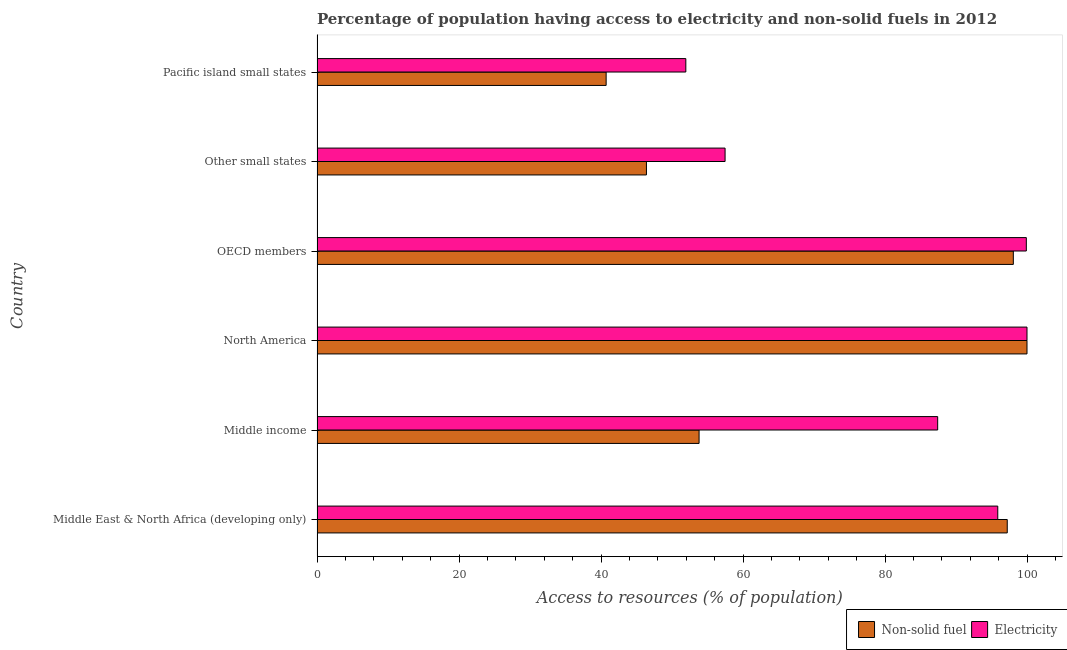How many different coloured bars are there?
Provide a succinct answer. 2. How many groups of bars are there?
Your answer should be very brief. 6. Are the number of bars on each tick of the Y-axis equal?
Offer a terse response. Yes. How many bars are there on the 6th tick from the top?
Provide a short and direct response. 2. How many bars are there on the 5th tick from the bottom?
Your answer should be very brief. 2. What is the label of the 1st group of bars from the top?
Provide a short and direct response. Pacific island small states. What is the percentage of population having access to non-solid fuel in Middle East & North Africa (developing only)?
Your answer should be compact. 97.22. Across all countries, what is the minimum percentage of population having access to non-solid fuel?
Keep it short and to the point. 40.72. In which country was the percentage of population having access to non-solid fuel minimum?
Make the answer very short. Pacific island small states. What is the total percentage of population having access to non-solid fuel in the graph?
Keep it short and to the point. 436.22. What is the difference between the percentage of population having access to non-solid fuel in Middle income and that in North America?
Your answer should be very brief. -46.19. What is the difference between the percentage of population having access to non-solid fuel in Pacific island small states and the percentage of population having access to electricity in OECD members?
Your answer should be compact. -59.19. What is the average percentage of population having access to non-solid fuel per country?
Keep it short and to the point. 72.7. What is the difference between the percentage of population having access to non-solid fuel and percentage of population having access to electricity in Middle East & North Africa (developing only)?
Make the answer very short. 1.34. What is the ratio of the percentage of population having access to electricity in Middle East & North Africa (developing only) to that in Middle income?
Keep it short and to the point. 1.1. Is the percentage of population having access to non-solid fuel in North America less than that in Pacific island small states?
Ensure brevity in your answer.  No. Is the difference between the percentage of population having access to non-solid fuel in Middle income and Pacific island small states greater than the difference between the percentage of population having access to electricity in Middle income and Pacific island small states?
Provide a succinct answer. No. What is the difference between the highest and the second highest percentage of population having access to electricity?
Offer a terse response. 0.09. What is the difference between the highest and the lowest percentage of population having access to electricity?
Your answer should be compact. 48.06. Is the sum of the percentage of population having access to electricity in Middle East & North Africa (developing only) and North America greater than the maximum percentage of population having access to non-solid fuel across all countries?
Give a very brief answer. Yes. What does the 2nd bar from the top in OECD members represents?
Offer a terse response. Non-solid fuel. What does the 1st bar from the bottom in North America represents?
Your answer should be compact. Non-solid fuel. What is the difference between two consecutive major ticks on the X-axis?
Give a very brief answer. 20. Does the graph contain any zero values?
Offer a very short reply. No. Does the graph contain grids?
Give a very brief answer. No. Where does the legend appear in the graph?
Ensure brevity in your answer.  Bottom right. What is the title of the graph?
Provide a succinct answer. Percentage of population having access to electricity and non-solid fuels in 2012. What is the label or title of the X-axis?
Provide a short and direct response. Access to resources (% of population). What is the Access to resources (% of population) in Non-solid fuel in Middle East & North Africa (developing only)?
Your response must be concise. 97.22. What is the Access to resources (% of population) of Electricity in Middle East & North Africa (developing only)?
Give a very brief answer. 95.88. What is the Access to resources (% of population) of Non-solid fuel in Middle income?
Your response must be concise. 53.81. What is the Access to resources (% of population) in Electricity in Middle income?
Your answer should be compact. 87.42. What is the Access to resources (% of population) of Non-solid fuel in North America?
Offer a terse response. 100. What is the Access to resources (% of population) of Electricity in North America?
Keep it short and to the point. 100. What is the Access to resources (% of population) in Non-solid fuel in OECD members?
Your response must be concise. 98.07. What is the Access to resources (% of population) of Electricity in OECD members?
Ensure brevity in your answer.  99.91. What is the Access to resources (% of population) of Non-solid fuel in Other small states?
Give a very brief answer. 46.4. What is the Access to resources (% of population) of Electricity in Other small states?
Your answer should be very brief. 57.47. What is the Access to resources (% of population) of Non-solid fuel in Pacific island small states?
Offer a terse response. 40.72. What is the Access to resources (% of population) in Electricity in Pacific island small states?
Keep it short and to the point. 51.94. Across all countries, what is the maximum Access to resources (% of population) of Non-solid fuel?
Offer a terse response. 100. Across all countries, what is the maximum Access to resources (% of population) of Electricity?
Offer a terse response. 100. Across all countries, what is the minimum Access to resources (% of population) of Non-solid fuel?
Make the answer very short. 40.72. Across all countries, what is the minimum Access to resources (% of population) in Electricity?
Provide a succinct answer. 51.94. What is the total Access to resources (% of population) of Non-solid fuel in the graph?
Provide a succinct answer. 436.22. What is the total Access to resources (% of population) of Electricity in the graph?
Your answer should be compact. 492.63. What is the difference between the Access to resources (% of population) in Non-solid fuel in Middle East & North Africa (developing only) and that in Middle income?
Ensure brevity in your answer.  43.41. What is the difference between the Access to resources (% of population) of Electricity in Middle East & North Africa (developing only) and that in Middle income?
Your response must be concise. 8.47. What is the difference between the Access to resources (% of population) of Non-solid fuel in Middle East & North Africa (developing only) and that in North America?
Your answer should be compact. -2.78. What is the difference between the Access to resources (% of population) in Electricity in Middle East & North Africa (developing only) and that in North America?
Provide a succinct answer. -4.12. What is the difference between the Access to resources (% of population) in Non-solid fuel in Middle East & North Africa (developing only) and that in OECD members?
Ensure brevity in your answer.  -0.85. What is the difference between the Access to resources (% of population) in Electricity in Middle East & North Africa (developing only) and that in OECD members?
Offer a terse response. -4.02. What is the difference between the Access to resources (% of population) of Non-solid fuel in Middle East & North Africa (developing only) and that in Other small states?
Your answer should be compact. 50.82. What is the difference between the Access to resources (% of population) of Electricity in Middle East & North Africa (developing only) and that in Other small states?
Provide a short and direct response. 38.41. What is the difference between the Access to resources (% of population) in Non-solid fuel in Middle East & North Africa (developing only) and that in Pacific island small states?
Your answer should be compact. 56.5. What is the difference between the Access to resources (% of population) of Electricity in Middle East & North Africa (developing only) and that in Pacific island small states?
Your response must be concise. 43.94. What is the difference between the Access to resources (% of population) of Non-solid fuel in Middle income and that in North America?
Offer a terse response. -46.19. What is the difference between the Access to resources (% of population) of Electricity in Middle income and that in North America?
Ensure brevity in your answer.  -12.58. What is the difference between the Access to resources (% of population) in Non-solid fuel in Middle income and that in OECD members?
Give a very brief answer. -44.26. What is the difference between the Access to resources (% of population) of Electricity in Middle income and that in OECD members?
Ensure brevity in your answer.  -12.49. What is the difference between the Access to resources (% of population) in Non-solid fuel in Middle income and that in Other small states?
Offer a very short reply. 7.41. What is the difference between the Access to resources (% of population) in Electricity in Middle income and that in Other small states?
Offer a very short reply. 29.94. What is the difference between the Access to resources (% of population) of Non-solid fuel in Middle income and that in Pacific island small states?
Make the answer very short. 13.09. What is the difference between the Access to resources (% of population) of Electricity in Middle income and that in Pacific island small states?
Give a very brief answer. 35.47. What is the difference between the Access to resources (% of population) of Non-solid fuel in North America and that in OECD members?
Offer a very short reply. 1.93. What is the difference between the Access to resources (% of population) in Electricity in North America and that in OECD members?
Your answer should be compact. 0.09. What is the difference between the Access to resources (% of population) of Non-solid fuel in North America and that in Other small states?
Your answer should be very brief. 53.6. What is the difference between the Access to resources (% of population) in Electricity in North America and that in Other small states?
Keep it short and to the point. 42.53. What is the difference between the Access to resources (% of population) of Non-solid fuel in North America and that in Pacific island small states?
Offer a very short reply. 59.28. What is the difference between the Access to resources (% of population) of Electricity in North America and that in Pacific island small states?
Give a very brief answer. 48.06. What is the difference between the Access to resources (% of population) in Non-solid fuel in OECD members and that in Other small states?
Give a very brief answer. 51.68. What is the difference between the Access to resources (% of population) of Electricity in OECD members and that in Other small states?
Provide a succinct answer. 42.43. What is the difference between the Access to resources (% of population) in Non-solid fuel in OECD members and that in Pacific island small states?
Your answer should be compact. 57.35. What is the difference between the Access to resources (% of population) of Electricity in OECD members and that in Pacific island small states?
Ensure brevity in your answer.  47.96. What is the difference between the Access to resources (% of population) in Non-solid fuel in Other small states and that in Pacific island small states?
Keep it short and to the point. 5.68. What is the difference between the Access to resources (% of population) in Electricity in Other small states and that in Pacific island small states?
Make the answer very short. 5.53. What is the difference between the Access to resources (% of population) of Non-solid fuel in Middle East & North Africa (developing only) and the Access to resources (% of population) of Electricity in Middle income?
Ensure brevity in your answer.  9.8. What is the difference between the Access to resources (% of population) of Non-solid fuel in Middle East & North Africa (developing only) and the Access to resources (% of population) of Electricity in North America?
Make the answer very short. -2.78. What is the difference between the Access to resources (% of population) of Non-solid fuel in Middle East & North Africa (developing only) and the Access to resources (% of population) of Electricity in OECD members?
Ensure brevity in your answer.  -2.69. What is the difference between the Access to resources (% of population) in Non-solid fuel in Middle East & North Africa (developing only) and the Access to resources (% of population) in Electricity in Other small states?
Ensure brevity in your answer.  39.75. What is the difference between the Access to resources (% of population) of Non-solid fuel in Middle East & North Africa (developing only) and the Access to resources (% of population) of Electricity in Pacific island small states?
Offer a very short reply. 45.28. What is the difference between the Access to resources (% of population) of Non-solid fuel in Middle income and the Access to resources (% of population) of Electricity in North America?
Give a very brief answer. -46.19. What is the difference between the Access to resources (% of population) in Non-solid fuel in Middle income and the Access to resources (% of population) in Electricity in OECD members?
Give a very brief answer. -46.1. What is the difference between the Access to resources (% of population) of Non-solid fuel in Middle income and the Access to resources (% of population) of Electricity in Other small states?
Offer a very short reply. -3.66. What is the difference between the Access to resources (% of population) of Non-solid fuel in Middle income and the Access to resources (% of population) of Electricity in Pacific island small states?
Give a very brief answer. 1.87. What is the difference between the Access to resources (% of population) in Non-solid fuel in North America and the Access to resources (% of population) in Electricity in OECD members?
Ensure brevity in your answer.  0.09. What is the difference between the Access to resources (% of population) of Non-solid fuel in North America and the Access to resources (% of population) of Electricity in Other small states?
Offer a terse response. 42.53. What is the difference between the Access to resources (% of population) in Non-solid fuel in North America and the Access to resources (% of population) in Electricity in Pacific island small states?
Keep it short and to the point. 48.06. What is the difference between the Access to resources (% of population) in Non-solid fuel in OECD members and the Access to resources (% of population) in Electricity in Other small states?
Provide a succinct answer. 40.6. What is the difference between the Access to resources (% of population) in Non-solid fuel in OECD members and the Access to resources (% of population) in Electricity in Pacific island small states?
Give a very brief answer. 46.13. What is the difference between the Access to resources (% of population) in Non-solid fuel in Other small states and the Access to resources (% of population) in Electricity in Pacific island small states?
Your answer should be very brief. -5.55. What is the average Access to resources (% of population) in Non-solid fuel per country?
Your answer should be very brief. 72.7. What is the average Access to resources (% of population) in Electricity per country?
Provide a short and direct response. 82.1. What is the difference between the Access to resources (% of population) in Non-solid fuel and Access to resources (% of population) in Electricity in Middle East & North Africa (developing only)?
Offer a very short reply. 1.34. What is the difference between the Access to resources (% of population) of Non-solid fuel and Access to resources (% of population) of Electricity in Middle income?
Make the answer very short. -33.61. What is the difference between the Access to resources (% of population) of Non-solid fuel and Access to resources (% of population) of Electricity in North America?
Offer a terse response. 0. What is the difference between the Access to resources (% of population) in Non-solid fuel and Access to resources (% of population) in Electricity in OECD members?
Make the answer very short. -1.83. What is the difference between the Access to resources (% of population) in Non-solid fuel and Access to resources (% of population) in Electricity in Other small states?
Provide a succinct answer. -11.08. What is the difference between the Access to resources (% of population) in Non-solid fuel and Access to resources (% of population) in Electricity in Pacific island small states?
Offer a very short reply. -11.22. What is the ratio of the Access to resources (% of population) of Non-solid fuel in Middle East & North Africa (developing only) to that in Middle income?
Provide a succinct answer. 1.81. What is the ratio of the Access to resources (% of population) in Electricity in Middle East & North Africa (developing only) to that in Middle income?
Keep it short and to the point. 1.1. What is the ratio of the Access to resources (% of population) in Non-solid fuel in Middle East & North Africa (developing only) to that in North America?
Your response must be concise. 0.97. What is the ratio of the Access to resources (% of population) in Electricity in Middle East & North Africa (developing only) to that in North America?
Offer a very short reply. 0.96. What is the ratio of the Access to resources (% of population) in Non-solid fuel in Middle East & North Africa (developing only) to that in OECD members?
Offer a very short reply. 0.99. What is the ratio of the Access to resources (% of population) of Electricity in Middle East & North Africa (developing only) to that in OECD members?
Give a very brief answer. 0.96. What is the ratio of the Access to resources (% of population) in Non-solid fuel in Middle East & North Africa (developing only) to that in Other small states?
Ensure brevity in your answer.  2.1. What is the ratio of the Access to resources (% of population) of Electricity in Middle East & North Africa (developing only) to that in Other small states?
Your response must be concise. 1.67. What is the ratio of the Access to resources (% of population) of Non-solid fuel in Middle East & North Africa (developing only) to that in Pacific island small states?
Ensure brevity in your answer.  2.39. What is the ratio of the Access to resources (% of population) in Electricity in Middle East & North Africa (developing only) to that in Pacific island small states?
Offer a very short reply. 1.85. What is the ratio of the Access to resources (% of population) in Non-solid fuel in Middle income to that in North America?
Your answer should be compact. 0.54. What is the ratio of the Access to resources (% of population) of Electricity in Middle income to that in North America?
Offer a very short reply. 0.87. What is the ratio of the Access to resources (% of population) in Non-solid fuel in Middle income to that in OECD members?
Give a very brief answer. 0.55. What is the ratio of the Access to resources (% of population) in Electricity in Middle income to that in OECD members?
Your answer should be very brief. 0.88. What is the ratio of the Access to resources (% of population) of Non-solid fuel in Middle income to that in Other small states?
Your answer should be compact. 1.16. What is the ratio of the Access to resources (% of population) in Electricity in Middle income to that in Other small states?
Give a very brief answer. 1.52. What is the ratio of the Access to resources (% of population) of Non-solid fuel in Middle income to that in Pacific island small states?
Your answer should be very brief. 1.32. What is the ratio of the Access to resources (% of population) in Electricity in Middle income to that in Pacific island small states?
Provide a succinct answer. 1.68. What is the ratio of the Access to resources (% of population) of Non-solid fuel in North America to that in OECD members?
Your answer should be compact. 1.02. What is the ratio of the Access to resources (% of population) in Electricity in North America to that in OECD members?
Give a very brief answer. 1. What is the ratio of the Access to resources (% of population) in Non-solid fuel in North America to that in Other small states?
Give a very brief answer. 2.16. What is the ratio of the Access to resources (% of population) of Electricity in North America to that in Other small states?
Ensure brevity in your answer.  1.74. What is the ratio of the Access to resources (% of population) of Non-solid fuel in North America to that in Pacific island small states?
Your answer should be compact. 2.46. What is the ratio of the Access to resources (% of population) of Electricity in North America to that in Pacific island small states?
Offer a terse response. 1.93. What is the ratio of the Access to resources (% of population) in Non-solid fuel in OECD members to that in Other small states?
Offer a terse response. 2.11. What is the ratio of the Access to resources (% of population) of Electricity in OECD members to that in Other small states?
Provide a short and direct response. 1.74. What is the ratio of the Access to resources (% of population) of Non-solid fuel in OECD members to that in Pacific island small states?
Give a very brief answer. 2.41. What is the ratio of the Access to resources (% of population) in Electricity in OECD members to that in Pacific island small states?
Your response must be concise. 1.92. What is the ratio of the Access to resources (% of population) in Non-solid fuel in Other small states to that in Pacific island small states?
Ensure brevity in your answer.  1.14. What is the ratio of the Access to resources (% of population) in Electricity in Other small states to that in Pacific island small states?
Ensure brevity in your answer.  1.11. What is the difference between the highest and the second highest Access to resources (% of population) in Non-solid fuel?
Make the answer very short. 1.93. What is the difference between the highest and the second highest Access to resources (% of population) of Electricity?
Your answer should be compact. 0.09. What is the difference between the highest and the lowest Access to resources (% of population) of Non-solid fuel?
Your answer should be very brief. 59.28. What is the difference between the highest and the lowest Access to resources (% of population) of Electricity?
Give a very brief answer. 48.06. 